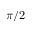<formula> <loc_0><loc_0><loc_500><loc_500>\pi / 2</formula> 